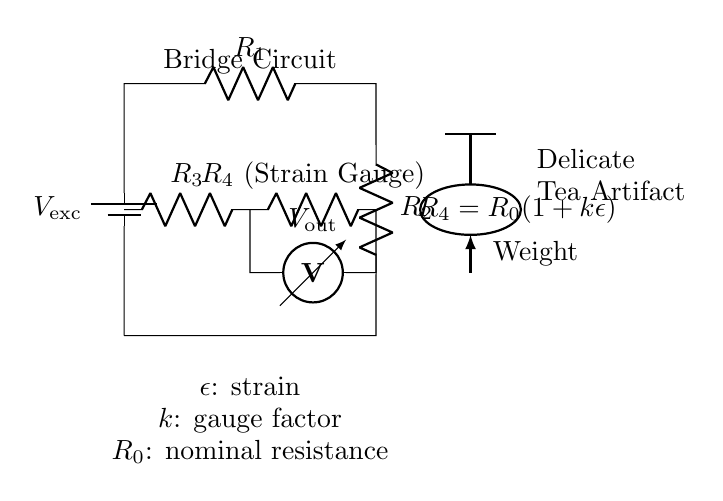What is the excitation voltage in this circuit? The excitation voltage, denoted as V_exc, is provided by the battery in the circuit diagram at the left side.
Answer: V_exc What resistance does the strain gauge represent? The strain gauge is represented by R_4 in the circuit, which is defined as R_0(1+kε) in the label next to it.
Answer: R_0(1+kε) How many resistors are in this circuit? The circuit contains four resistors, labeled R_1, R_2, R_3, and R_4.
Answer: Four What happens to R_4 when strain ε is applied? When strain ε is applied, R_4 changes according to the equation provided, indicating that its resistance increases or decreases depending on the strain value.
Answer: R_4 changes What does the voltmeter measure? The voltmeter measures the output voltage, denoted as V_out, which is the potential difference between two points in the bridge circuit.
Answer: V_out What is the purpose of the bridge circuit? The purpose of the bridge circuit is to measure weight with high accuracy, using the change in resistance of the strain gauge when the delicate tea artifact is placed on it.
Answer: Measure weight accurately Which component is specifically used for measuring strain? The component used for measuring strain in the circuit is the strain gauge, labeled as R_4.
Answer: Strain gauge 